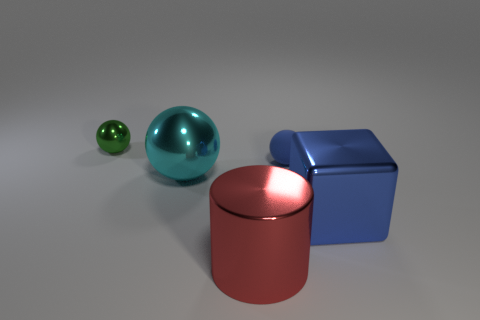Are there any other things that are the same material as the small blue ball?
Your answer should be compact. No. How many other things have the same shape as the small green metallic object?
Provide a succinct answer. 2. There is a large metallic thing that is behind the large shiny block; is it the same color as the metallic object that is behind the matte sphere?
Provide a short and direct response. No. What number of objects are small cyan rubber spheres or blue objects?
Ensure brevity in your answer.  2. How many other large things are made of the same material as the large blue object?
Provide a short and direct response. 2. Are there fewer small blue metallic blocks than big cylinders?
Make the answer very short. Yes. Does the large object that is to the left of the cylinder have the same material as the blue ball?
Your response must be concise. No. How many spheres are either cyan shiny things or tiny blue things?
Provide a succinct answer. 2. There is a big thing that is both behind the big red cylinder and left of the large blue object; what shape is it?
Your answer should be very brief. Sphere. There is a tiny object that is in front of the small thing that is behind the tiny object right of the large cylinder; what is its color?
Ensure brevity in your answer.  Blue. 